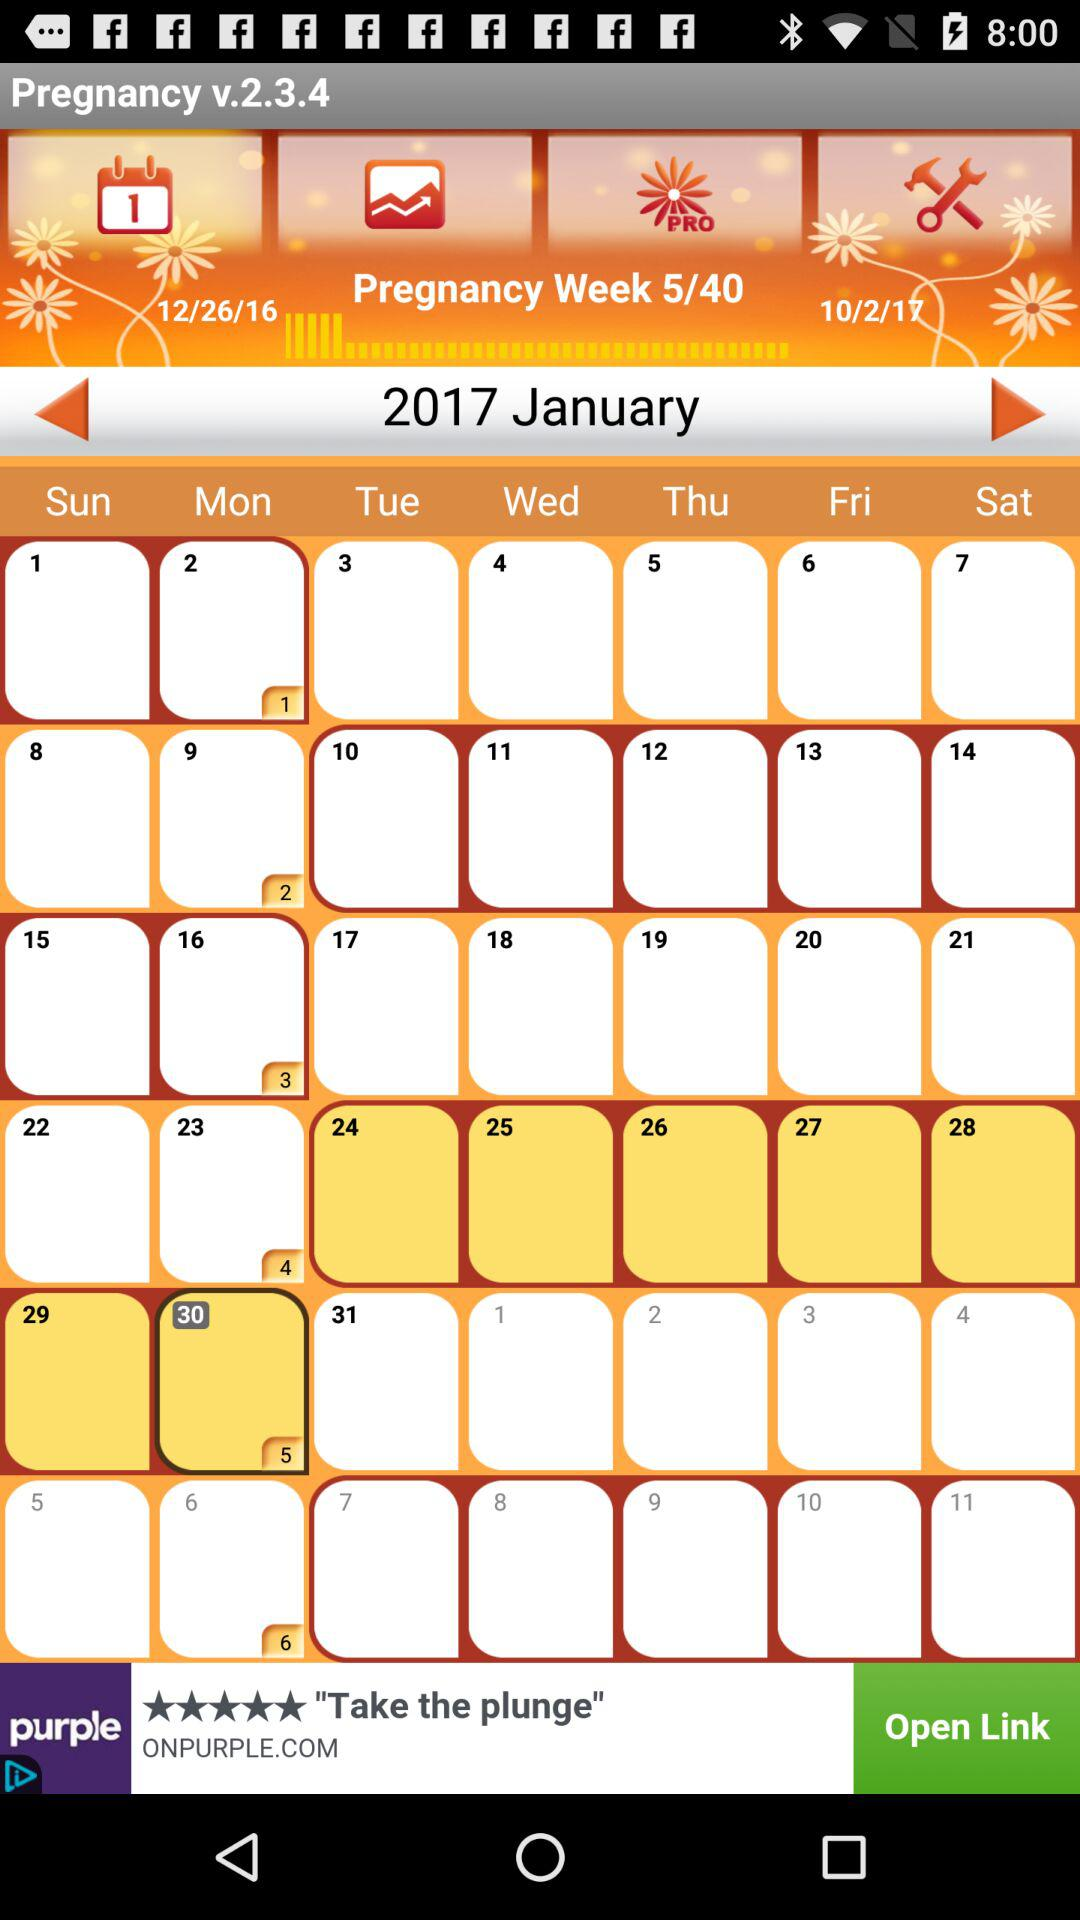How many total weeks of pregnancy are given? The total weeks of pregnancy given are 40. 